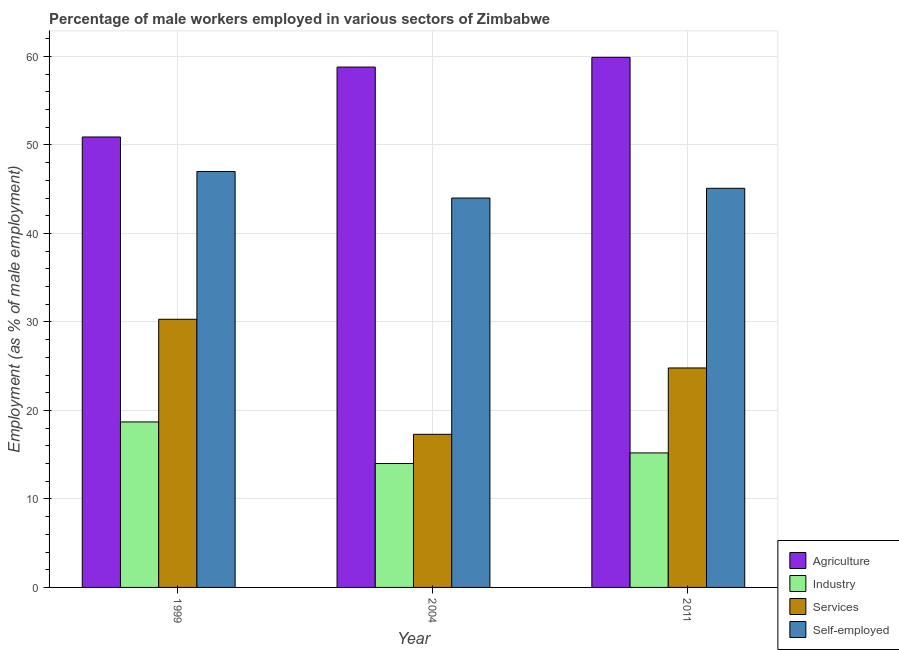How many different coloured bars are there?
Your answer should be compact. 4. Are the number of bars per tick equal to the number of legend labels?
Your response must be concise. Yes. Are the number of bars on each tick of the X-axis equal?
Offer a terse response. Yes. What is the label of the 1st group of bars from the left?
Provide a short and direct response. 1999. In how many cases, is the number of bars for a given year not equal to the number of legend labels?
Make the answer very short. 0. What is the percentage of male workers in agriculture in 1999?
Provide a short and direct response. 50.9. Across all years, what is the maximum percentage of male workers in services?
Provide a short and direct response. 30.3. Across all years, what is the minimum percentage of male workers in industry?
Your answer should be very brief. 14. In which year was the percentage of male workers in agriculture maximum?
Your response must be concise. 2011. What is the total percentage of male workers in services in the graph?
Your response must be concise. 72.4. What is the difference between the percentage of male workers in industry in 1999 and that in 2004?
Give a very brief answer. 4.7. What is the difference between the percentage of male workers in agriculture in 2004 and the percentage of male workers in industry in 1999?
Give a very brief answer. 7.9. What is the average percentage of male workers in industry per year?
Make the answer very short. 15.97. In how many years, is the percentage of male workers in services greater than 38 %?
Your response must be concise. 0. What is the ratio of the percentage of self employed male workers in 1999 to that in 2011?
Offer a terse response. 1.04. What is the difference between the highest and the lowest percentage of self employed male workers?
Provide a succinct answer. 3. Is the sum of the percentage of male workers in industry in 2004 and 2011 greater than the maximum percentage of male workers in agriculture across all years?
Your answer should be very brief. Yes. What does the 4th bar from the left in 1999 represents?
Your answer should be compact. Self-employed. What does the 4th bar from the right in 2004 represents?
Provide a short and direct response. Agriculture. Are all the bars in the graph horizontal?
Your answer should be very brief. No. How many years are there in the graph?
Offer a very short reply. 3. Does the graph contain grids?
Your response must be concise. Yes. How are the legend labels stacked?
Your answer should be very brief. Vertical. What is the title of the graph?
Your response must be concise. Percentage of male workers employed in various sectors of Zimbabwe. What is the label or title of the Y-axis?
Give a very brief answer. Employment (as % of male employment). What is the Employment (as % of male employment) of Agriculture in 1999?
Offer a very short reply. 50.9. What is the Employment (as % of male employment) of Industry in 1999?
Offer a very short reply. 18.7. What is the Employment (as % of male employment) in Services in 1999?
Offer a very short reply. 30.3. What is the Employment (as % of male employment) in Self-employed in 1999?
Provide a succinct answer. 47. What is the Employment (as % of male employment) of Agriculture in 2004?
Your answer should be very brief. 58.8. What is the Employment (as % of male employment) of Services in 2004?
Ensure brevity in your answer.  17.3. What is the Employment (as % of male employment) in Self-employed in 2004?
Offer a terse response. 44. What is the Employment (as % of male employment) of Agriculture in 2011?
Offer a very short reply. 59.9. What is the Employment (as % of male employment) of Industry in 2011?
Offer a very short reply. 15.2. What is the Employment (as % of male employment) of Services in 2011?
Provide a succinct answer. 24.8. What is the Employment (as % of male employment) in Self-employed in 2011?
Make the answer very short. 45.1. Across all years, what is the maximum Employment (as % of male employment) of Agriculture?
Make the answer very short. 59.9. Across all years, what is the maximum Employment (as % of male employment) of Industry?
Give a very brief answer. 18.7. Across all years, what is the maximum Employment (as % of male employment) in Services?
Your answer should be very brief. 30.3. Across all years, what is the minimum Employment (as % of male employment) in Agriculture?
Make the answer very short. 50.9. Across all years, what is the minimum Employment (as % of male employment) in Industry?
Ensure brevity in your answer.  14. Across all years, what is the minimum Employment (as % of male employment) in Services?
Provide a short and direct response. 17.3. What is the total Employment (as % of male employment) in Agriculture in the graph?
Offer a very short reply. 169.6. What is the total Employment (as % of male employment) of Industry in the graph?
Your answer should be very brief. 47.9. What is the total Employment (as % of male employment) in Services in the graph?
Keep it short and to the point. 72.4. What is the total Employment (as % of male employment) in Self-employed in the graph?
Your answer should be compact. 136.1. What is the difference between the Employment (as % of male employment) of Agriculture in 1999 and that in 2004?
Ensure brevity in your answer.  -7.9. What is the difference between the Employment (as % of male employment) of Industry in 1999 and that in 2004?
Ensure brevity in your answer.  4.7. What is the difference between the Employment (as % of male employment) in Services in 1999 and that in 2004?
Give a very brief answer. 13. What is the difference between the Employment (as % of male employment) in Self-employed in 1999 and that in 2004?
Offer a terse response. 3. What is the difference between the Employment (as % of male employment) in Services in 1999 and that in 2011?
Keep it short and to the point. 5.5. What is the difference between the Employment (as % of male employment) in Self-employed in 1999 and that in 2011?
Make the answer very short. 1.9. What is the difference between the Employment (as % of male employment) in Industry in 2004 and that in 2011?
Your answer should be compact. -1.2. What is the difference between the Employment (as % of male employment) in Agriculture in 1999 and the Employment (as % of male employment) in Industry in 2004?
Your answer should be compact. 36.9. What is the difference between the Employment (as % of male employment) in Agriculture in 1999 and the Employment (as % of male employment) in Services in 2004?
Keep it short and to the point. 33.6. What is the difference between the Employment (as % of male employment) of Industry in 1999 and the Employment (as % of male employment) of Self-employed in 2004?
Keep it short and to the point. -25.3. What is the difference between the Employment (as % of male employment) in Services in 1999 and the Employment (as % of male employment) in Self-employed in 2004?
Your answer should be compact. -13.7. What is the difference between the Employment (as % of male employment) of Agriculture in 1999 and the Employment (as % of male employment) of Industry in 2011?
Provide a short and direct response. 35.7. What is the difference between the Employment (as % of male employment) in Agriculture in 1999 and the Employment (as % of male employment) in Services in 2011?
Your response must be concise. 26.1. What is the difference between the Employment (as % of male employment) in Industry in 1999 and the Employment (as % of male employment) in Self-employed in 2011?
Your response must be concise. -26.4. What is the difference between the Employment (as % of male employment) of Services in 1999 and the Employment (as % of male employment) of Self-employed in 2011?
Offer a very short reply. -14.8. What is the difference between the Employment (as % of male employment) of Agriculture in 2004 and the Employment (as % of male employment) of Industry in 2011?
Give a very brief answer. 43.6. What is the difference between the Employment (as % of male employment) of Agriculture in 2004 and the Employment (as % of male employment) of Services in 2011?
Your response must be concise. 34. What is the difference between the Employment (as % of male employment) of Agriculture in 2004 and the Employment (as % of male employment) of Self-employed in 2011?
Make the answer very short. 13.7. What is the difference between the Employment (as % of male employment) in Industry in 2004 and the Employment (as % of male employment) in Self-employed in 2011?
Provide a succinct answer. -31.1. What is the difference between the Employment (as % of male employment) in Services in 2004 and the Employment (as % of male employment) in Self-employed in 2011?
Provide a succinct answer. -27.8. What is the average Employment (as % of male employment) in Agriculture per year?
Make the answer very short. 56.53. What is the average Employment (as % of male employment) of Industry per year?
Your answer should be very brief. 15.97. What is the average Employment (as % of male employment) in Services per year?
Keep it short and to the point. 24.13. What is the average Employment (as % of male employment) of Self-employed per year?
Keep it short and to the point. 45.37. In the year 1999, what is the difference between the Employment (as % of male employment) in Agriculture and Employment (as % of male employment) in Industry?
Provide a short and direct response. 32.2. In the year 1999, what is the difference between the Employment (as % of male employment) of Agriculture and Employment (as % of male employment) of Services?
Make the answer very short. 20.6. In the year 1999, what is the difference between the Employment (as % of male employment) in Agriculture and Employment (as % of male employment) in Self-employed?
Provide a short and direct response. 3.9. In the year 1999, what is the difference between the Employment (as % of male employment) of Industry and Employment (as % of male employment) of Self-employed?
Provide a succinct answer. -28.3. In the year 1999, what is the difference between the Employment (as % of male employment) of Services and Employment (as % of male employment) of Self-employed?
Offer a terse response. -16.7. In the year 2004, what is the difference between the Employment (as % of male employment) in Agriculture and Employment (as % of male employment) in Industry?
Provide a succinct answer. 44.8. In the year 2004, what is the difference between the Employment (as % of male employment) of Agriculture and Employment (as % of male employment) of Services?
Ensure brevity in your answer.  41.5. In the year 2004, what is the difference between the Employment (as % of male employment) in Industry and Employment (as % of male employment) in Self-employed?
Provide a short and direct response. -30. In the year 2004, what is the difference between the Employment (as % of male employment) of Services and Employment (as % of male employment) of Self-employed?
Keep it short and to the point. -26.7. In the year 2011, what is the difference between the Employment (as % of male employment) of Agriculture and Employment (as % of male employment) of Industry?
Your answer should be very brief. 44.7. In the year 2011, what is the difference between the Employment (as % of male employment) in Agriculture and Employment (as % of male employment) in Services?
Provide a succinct answer. 35.1. In the year 2011, what is the difference between the Employment (as % of male employment) in Industry and Employment (as % of male employment) in Self-employed?
Provide a short and direct response. -29.9. In the year 2011, what is the difference between the Employment (as % of male employment) of Services and Employment (as % of male employment) of Self-employed?
Provide a short and direct response. -20.3. What is the ratio of the Employment (as % of male employment) of Agriculture in 1999 to that in 2004?
Ensure brevity in your answer.  0.87. What is the ratio of the Employment (as % of male employment) in Industry in 1999 to that in 2004?
Your answer should be compact. 1.34. What is the ratio of the Employment (as % of male employment) of Services in 1999 to that in 2004?
Provide a short and direct response. 1.75. What is the ratio of the Employment (as % of male employment) in Self-employed in 1999 to that in 2004?
Give a very brief answer. 1.07. What is the ratio of the Employment (as % of male employment) of Agriculture in 1999 to that in 2011?
Offer a terse response. 0.85. What is the ratio of the Employment (as % of male employment) in Industry in 1999 to that in 2011?
Your answer should be very brief. 1.23. What is the ratio of the Employment (as % of male employment) of Services in 1999 to that in 2011?
Offer a very short reply. 1.22. What is the ratio of the Employment (as % of male employment) in Self-employed in 1999 to that in 2011?
Your answer should be compact. 1.04. What is the ratio of the Employment (as % of male employment) in Agriculture in 2004 to that in 2011?
Offer a very short reply. 0.98. What is the ratio of the Employment (as % of male employment) in Industry in 2004 to that in 2011?
Provide a short and direct response. 0.92. What is the ratio of the Employment (as % of male employment) of Services in 2004 to that in 2011?
Your answer should be compact. 0.7. What is the ratio of the Employment (as % of male employment) in Self-employed in 2004 to that in 2011?
Ensure brevity in your answer.  0.98. What is the difference between the highest and the second highest Employment (as % of male employment) in Industry?
Keep it short and to the point. 3.5. What is the difference between the highest and the second highest Employment (as % of male employment) in Services?
Your response must be concise. 5.5. What is the difference between the highest and the lowest Employment (as % of male employment) of Self-employed?
Offer a terse response. 3. 